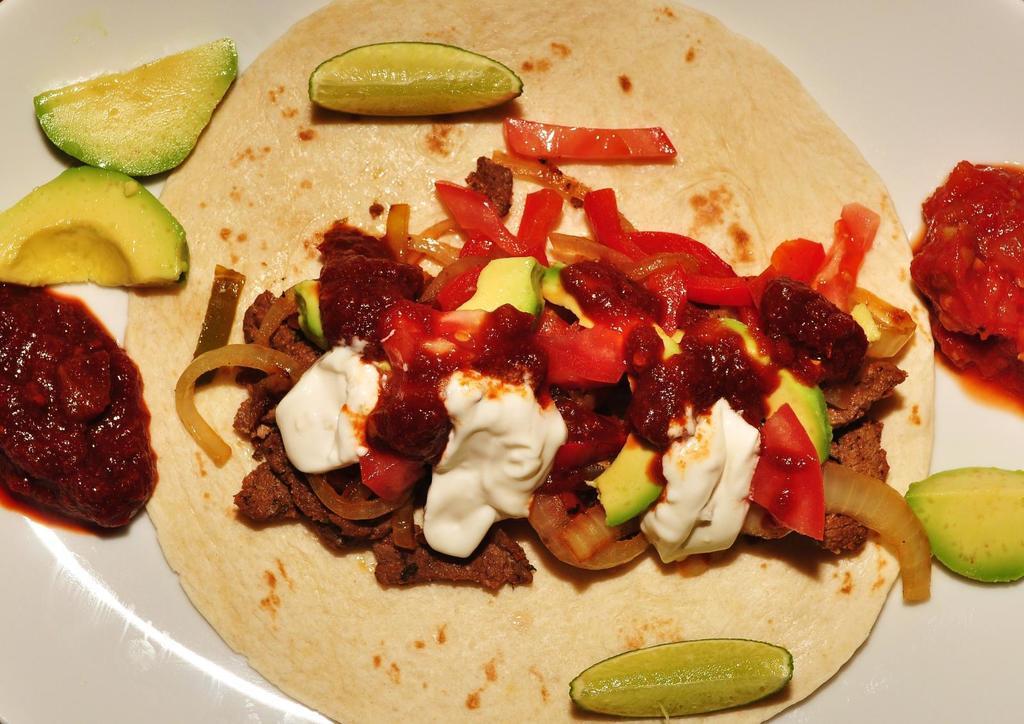Please provide a concise description of this image. In this image we can see some food items placed in a plate in that there are tomatoes ,onions. 